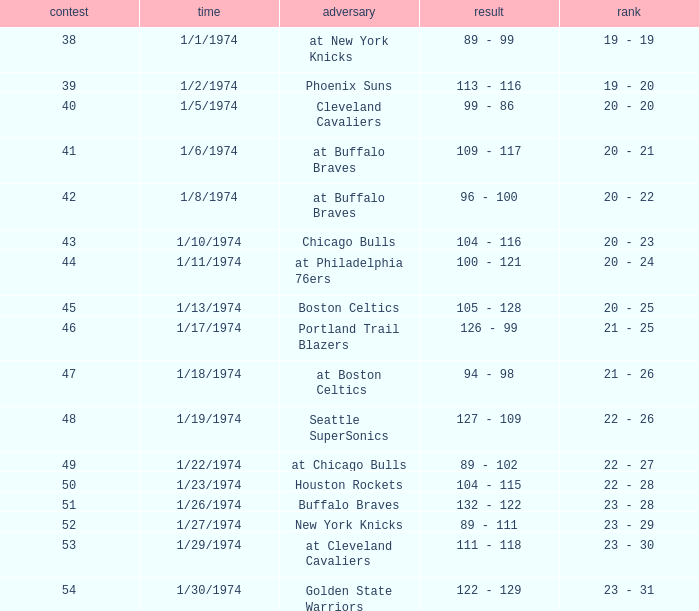What opponent played on 1/13/1974? Boston Celtics. 